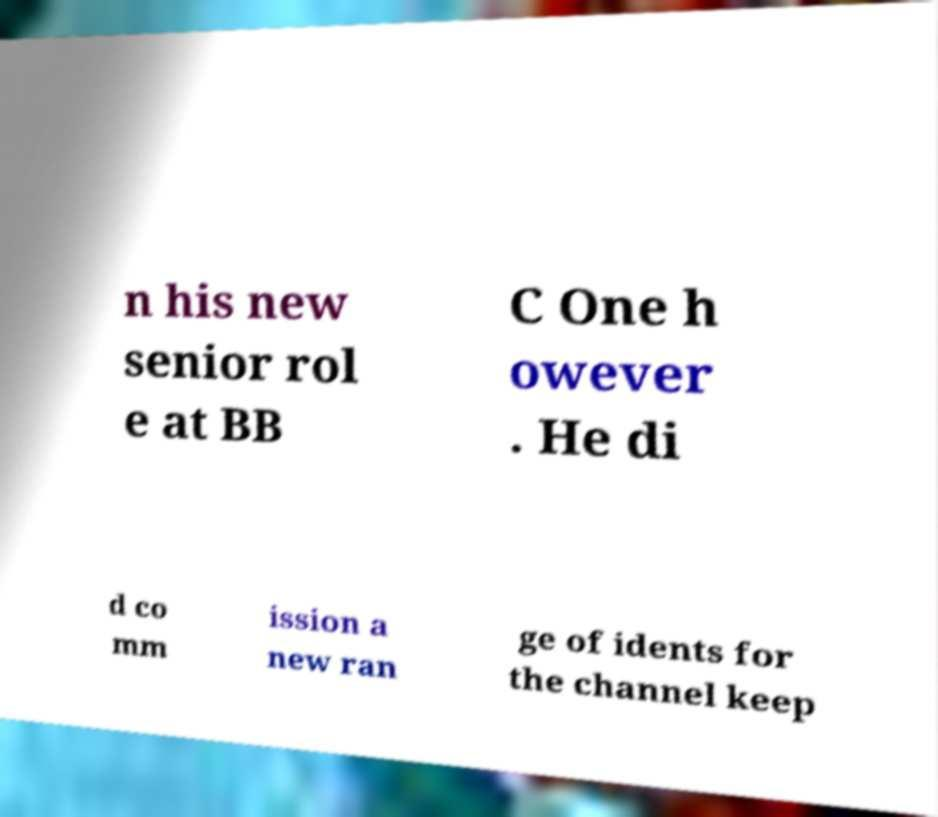Please identify and transcribe the text found in this image. n his new senior rol e at BB C One h owever . He di d co mm ission a new ran ge of idents for the channel keep 